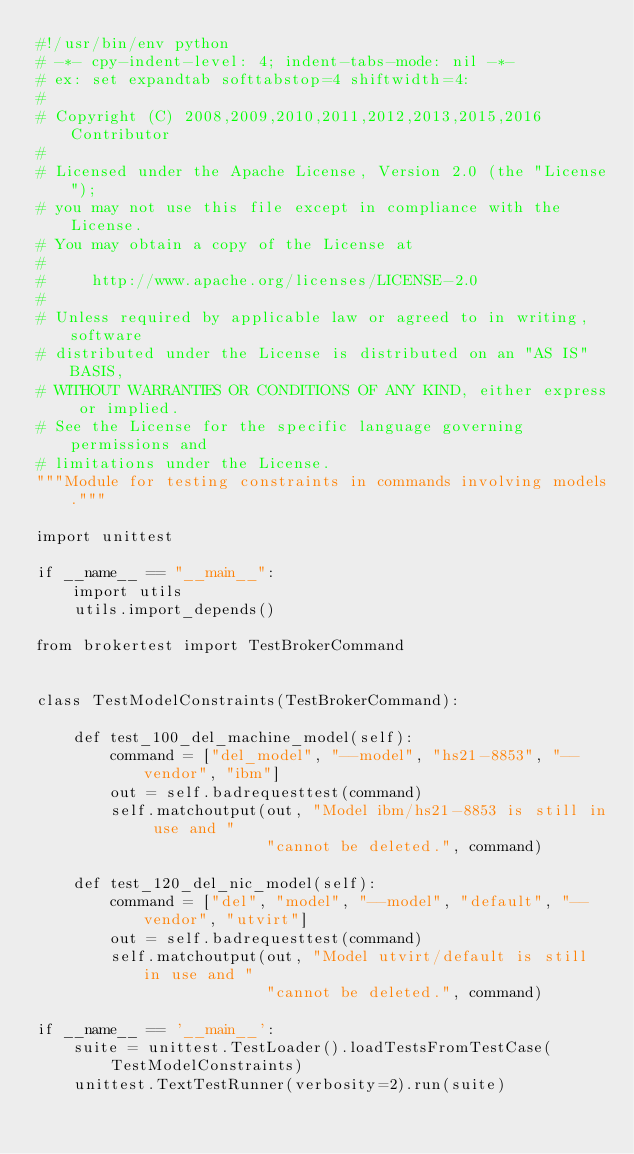Convert code to text. <code><loc_0><loc_0><loc_500><loc_500><_Python_>#!/usr/bin/env python
# -*- cpy-indent-level: 4; indent-tabs-mode: nil -*-
# ex: set expandtab softtabstop=4 shiftwidth=4:
#
# Copyright (C) 2008,2009,2010,2011,2012,2013,2015,2016  Contributor
#
# Licensed under the Apache License, Version 2.0 (the "License");
# you may not use this file except in compliance with the License.
# You may obtain a copy of the License at
#
#     http://www.apache.org/licenses/LICENSE-2.0
#
# Unless required by applicable law or agreed to in writing, software
# distributed under the License is distributed on an "AS IS" BASIS,
# WITHOUT WARRANTIES OR CONDITIONS OF ANY KIND, either express or implied.
# See the License for the specific language governing permissions and
# limitations under the License.
"""Module for testing constraints in commands involving models."""

import unittest

if __name__ == "__main__":
    import utils
    utils.import_depends()

from brokertest import TestBrokerCommand


class TestModelConstraints(TestBrokerCommand):

    def test_100_del_machine_model(self):
        command = ["del_model", "--model", "hs21-8853", "--vendor", "ibm"]
        out = self.badrequesttest(command)
        self.matchoutput(out, "Model ibm/hs21-8853 is still in use and "
                         "cannot be deleted.", command)

    def test_120_del_nic_model(self):
        command = ["del", "model", "--model", "default", "--vendor", "utvirt"]
        out = self.badrequesttest(command)
        self.matchoutput(out, "Model utvirt/default is still in use and "
                         "cannot be deleted.", command)

if __name__ == '__main__':
    suite = unittest.TestLoader().loadTestsFromTestCase(
        TestModelConstraints)
    unittest.TextTestRunner(verbosity=2).run(suite)
</code> 